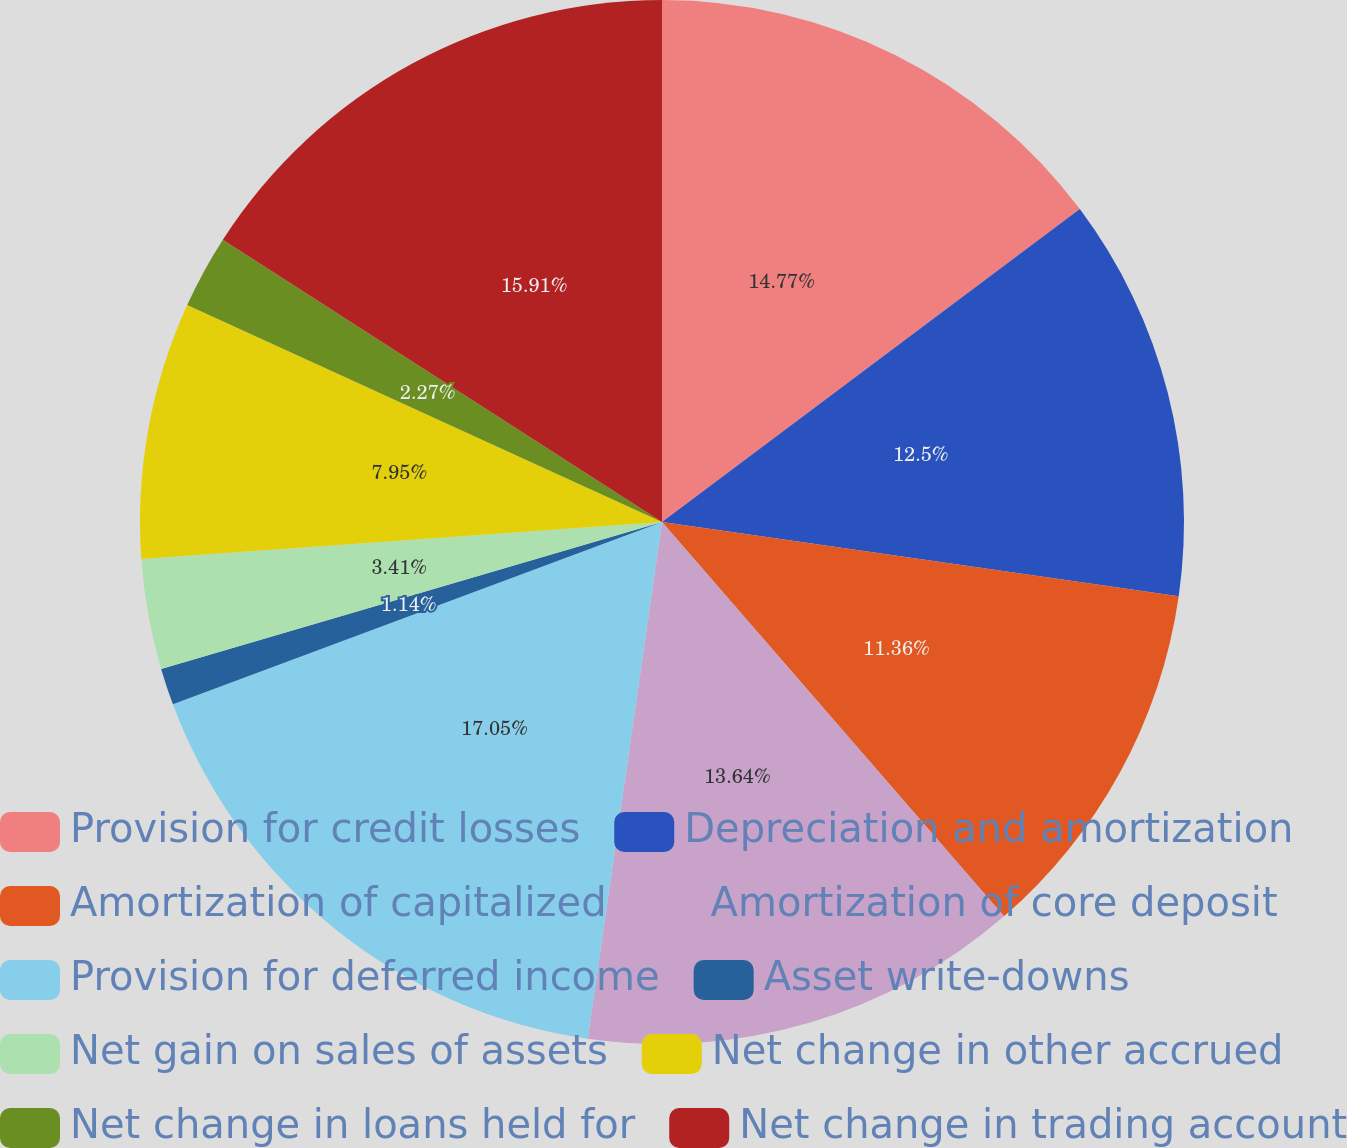Convert chart. <chart><loc_0><loc_0><loc_500><loc_500><pie_chart><fcel>Provision for credit losses<fcel>Depreciation and amortization<fcel>Amortization of capitalized<fcel>Amortization of core deposit<fcel>Provision for deferred income<fcel>Asset write-downs<fcel>Net gain on sales of assets<fcel>Net change in other accrued<fcel>Net change in loans held for<fcel>Net change in trading account<nl><fcel>14.77%<fcel>12.5%<fcel>11.36%<fcel>13.64%<fcel>17.05%<fcel>1.14%<fcel>3.41%<fcel>7.95%<fcel>2.27%<fcel>15.91%<nl></chart> 